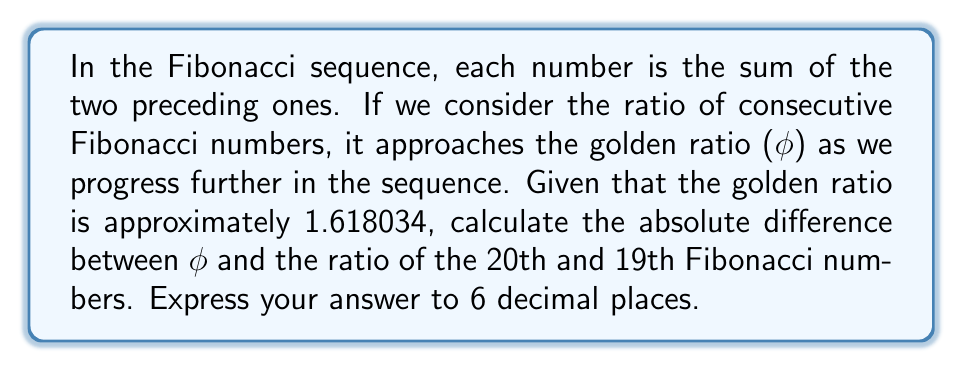Help me with this question. Let's approach this step-by-step:

1) First, we need to calculate the 19th and 20th Fibonacci numbers.

2) The Fibonacci sequence starts with 0 and 1, and each subsequent number is the sum of the two preceding ones. Let's calculate the first 20 numbers:

   $$F_1 = 1, F_2 = 1, F_3 = 2, F_4 = 3, F_5 = 5, F_6 = 8, F_7 = 13, F_8 = 21, F_9 = 34, F_{10} = 55,$$
   $$F_{11} = 89, F_{12} = 144, F_{13} = 233, F_{14} = 377, F_{15} = 610, F_{16} = 987,$$
   $$F_{17} = 1597, F_{18} = 2584, F_{19} = 4181, F_{20} = 6765$$

3) Now we need to calculate the ratio of $F_{20}$ to $F_{19}$:

   $$\frac{F_{20}}{F_{19}} = \frac{6765}{4181} \approx 1.618033989$$

4) The golden ratio $\phi$ is approximately 1.618034

5) To find the absolute difference, we subtract these values and take the absolute value:

   $$|\phi - \frac{F_{20}}{F_{19}}| = |1.618034 - 1.618033989| = 0.000000011$$

6) Rounding to 6 decimal places gives us 0.000000.
Answer: 0.000000 